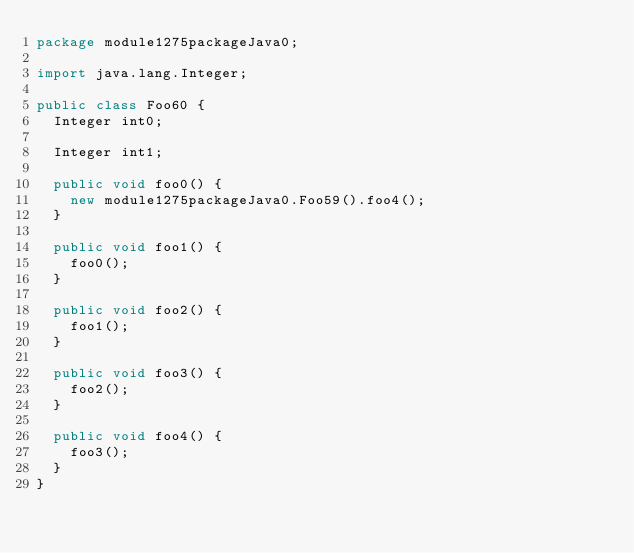Convert code to text. <code><loc_0><loc_0><loc_500><loc_500><_Java_>package module1275packageJava0;

import java.lang.Integer;

public class Foo60 {
  Integer int0;

  Integer int1;

  public void foo0() {
    new module1275packageJava0.Foo59().foo4();
  }

  public void foo1() {
    foo0();
  }

  public void foo2() {
    foo1();
  }

  public void foo3() {
    foo2();
  }

  public void foo4() {
    foo3();
  }
}
</code> 